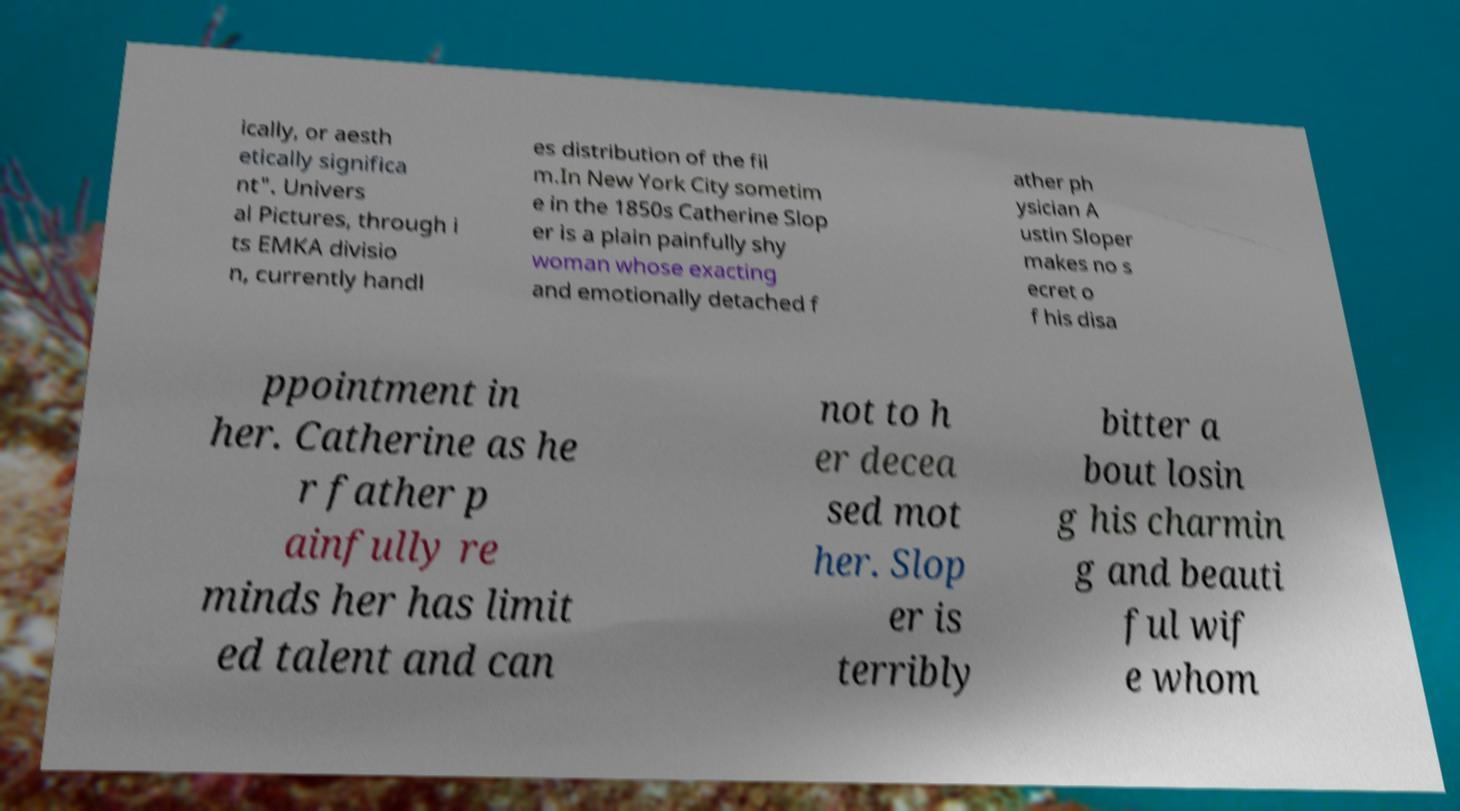For documentation purposes, I need the text within this image transcribed. Could you provide that? ically, or aesth etically significa nt". Univers al Pictures, through i ts EMKA divisio n, currently handl es distribution of the fil m.In New York City sometim e in the 1850s Catherine Slop er is a plain painfully shy woman whose exacting and emotionally detached f ather ph ysician A ustin Sloper makes no s ecret o f his disa ppointment in her. Catherine as he r father p ainfully re minds her has limit ed talent and can not to h er decea sed mot her. Slop er is terribly bitter a bout losin g his charmin g and beauti ful wif e whom 